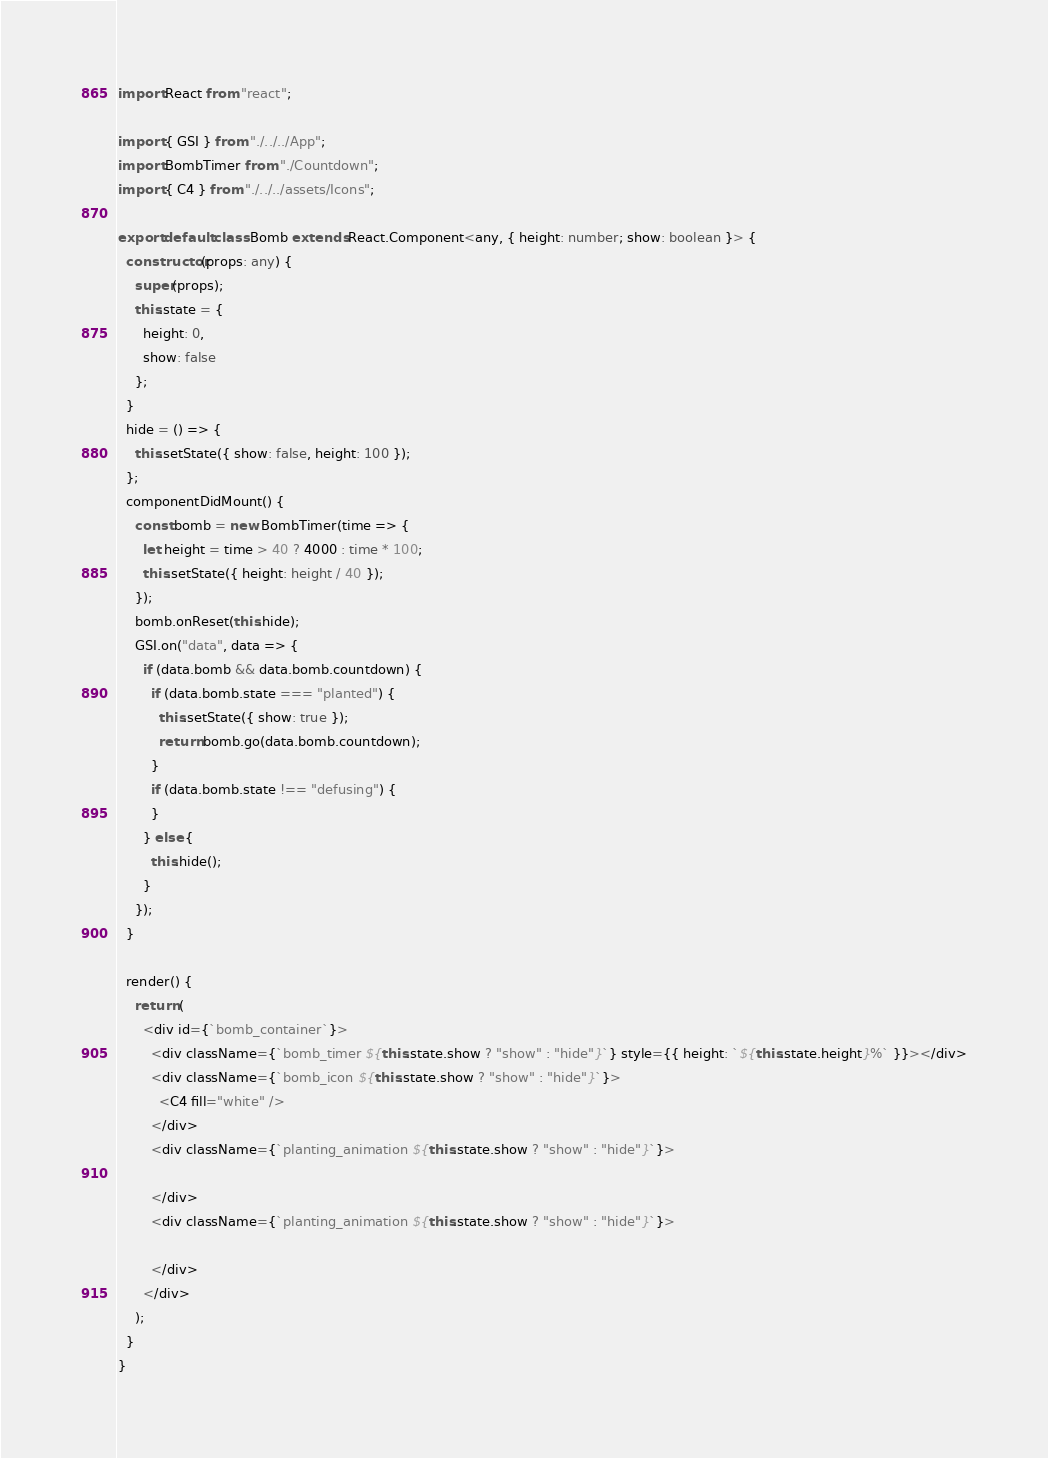<code> <loc_0><loc_0><loc_500><loc_500><_TypeScript_>import React from "react";

import { GSI } from "./../../App";
import BombTimer from "./Countdown";
import { C4 } from "./../../assets/Icons";

export default class Bomb extends React.Component<any, { height: number; show: boolean }> {
  constructor(props: any) {
    super(props);
    this.state = {
      height: 0,
      show: false
    };
  }
  hide = () => {
    this.setState({ show: false, height: 100 });
  };
  componentDidMount() {
    const bomb = new BombTimer(time => {
      let height = time > 40 ? 4000 : time * 100;
      this.setState({ height: height / 40 });
    });
    bomb.onReset(this.hide);
    GSI.on("data", data => {
      if (data.bomb && data.bomb.countdown) {
        if (data.bomb.state === "planted") {
          this.setState({ show: true });
          return bomb.go(data.bomb.countdown);
        }
        if (data.bomb.state !== "defusing") {
        }
      } else {
        this.hide();
      }
    });
  }

  render() {
    return (
      <div id={`bomb_container`}>
        <div className={`bomb_timer ${this.state.show ? "show" : "hide"}`} style={{ height: `${this.state.height}%` }}></div>
        <div className={`bomb_icon ${this.state.show ? "show" : "hide"}`}>
          <C4 fill="white" />
        </div>
        <div className={`planting_animation ${this.state.show ? "show" : "hide"}`}>

        </div>
        <div className={`planting_animation ${this.state.show ? "show" : "hide"}`}>

        </div>
      </div>
    );
  }
}
</code> 